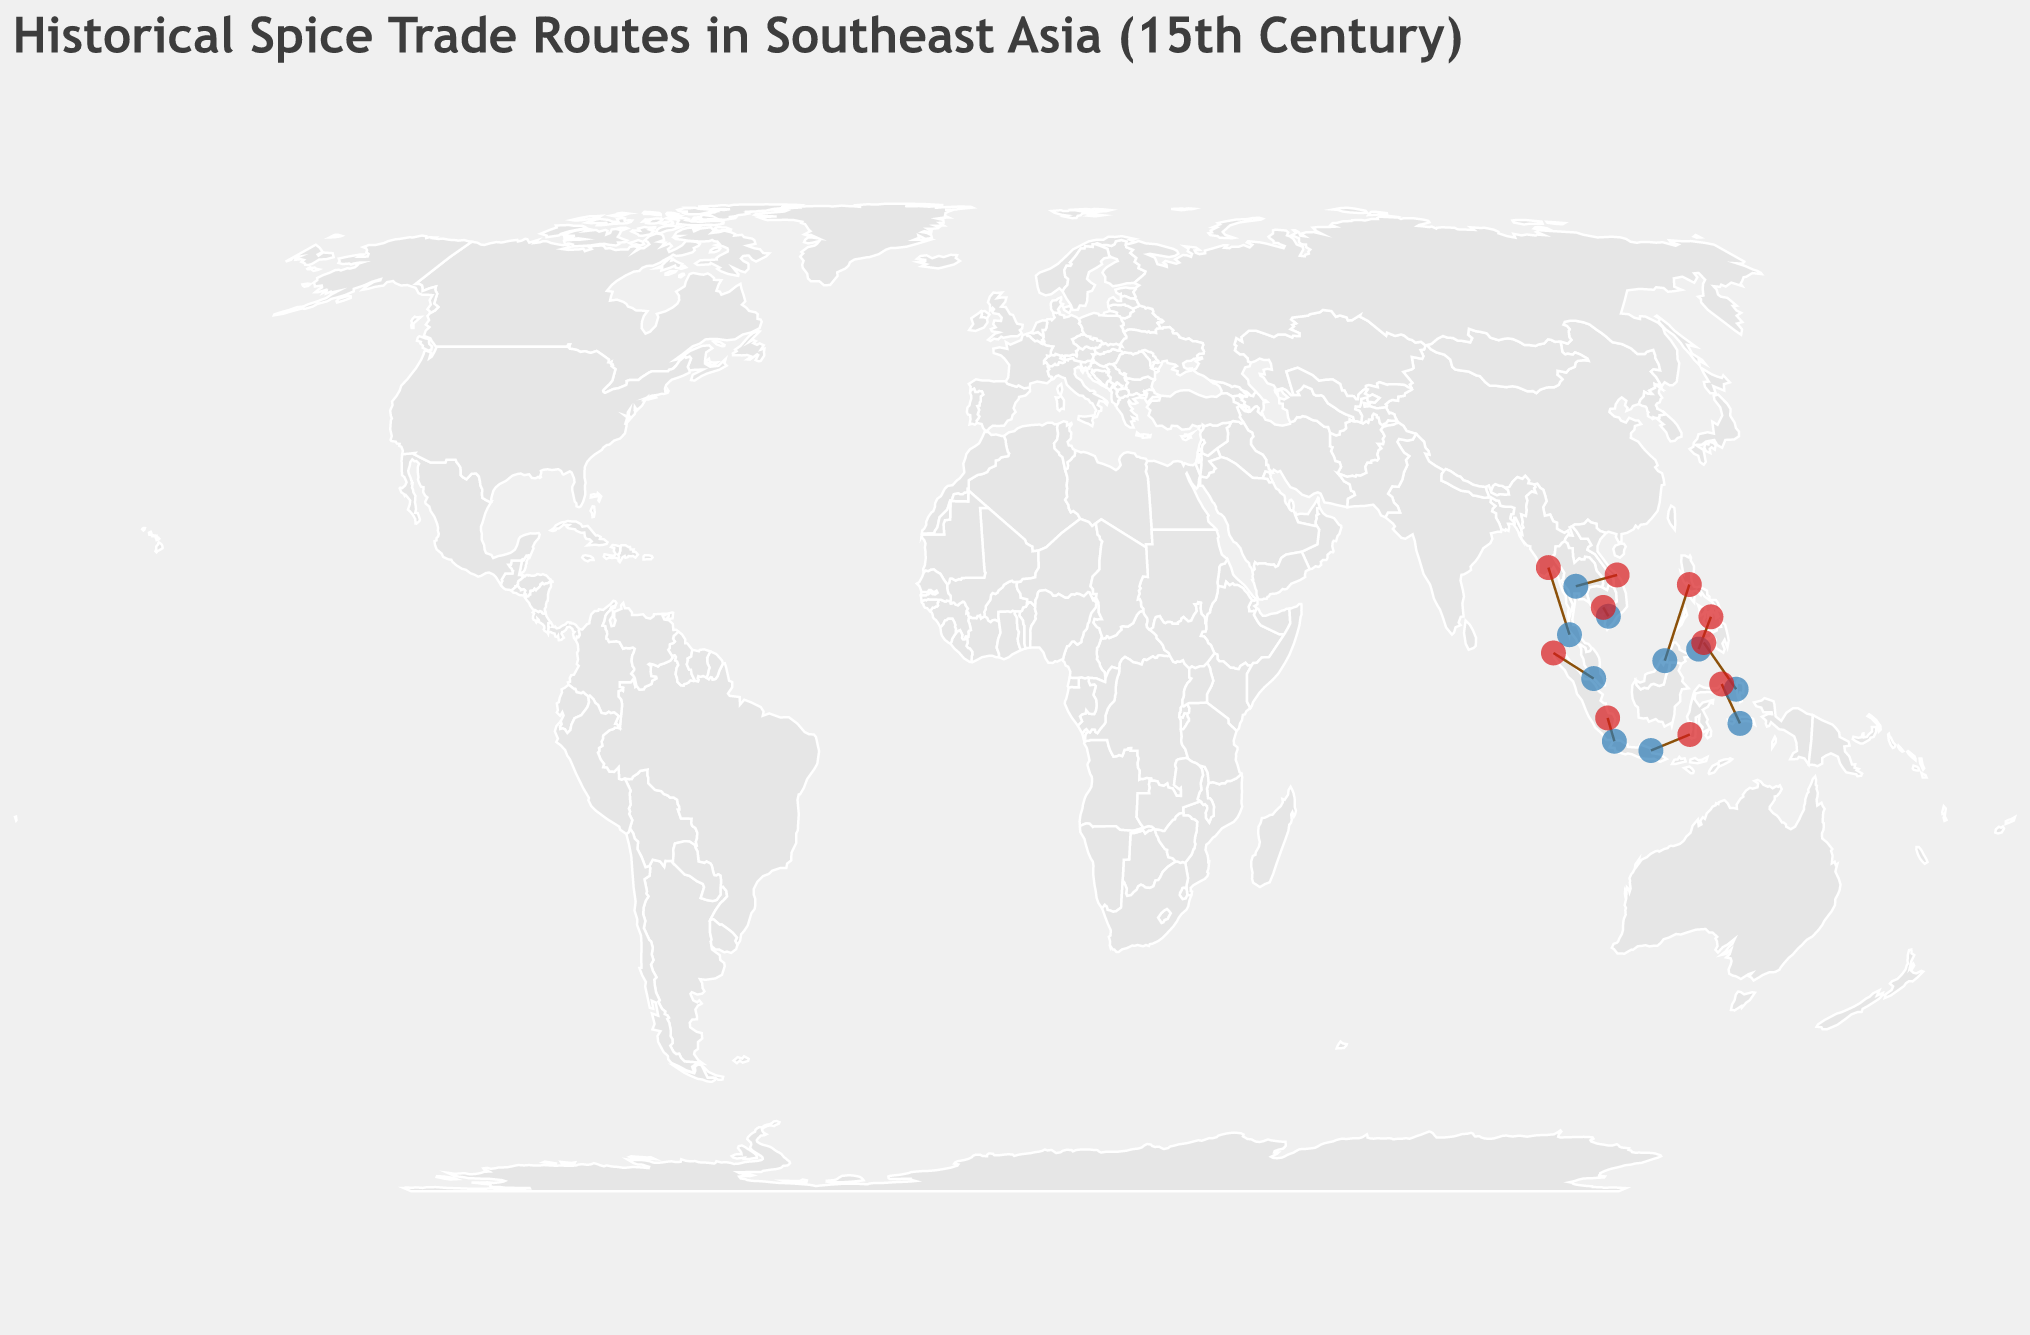What is the title of the figure? The title is prominently displayed at the top of the figure, written in a larger font size. The title reads: "Historical Spice Trade Routes in Southeast Asia (15th Century)."
Answer: Historical Spice Trade Routes in Southeast Asia (15th Century) Which spice had the highest trade volume, and on which route was it traded? By reviewing the tooltips or data points, the highest trade volume is for Black Pepper with a volume of 300 tons/year on the Java Sea Route from Surabaya to Makassar.
Answer: Black Pepper, Java Sea Route What are the start and end points of the Andaman Sea Route? By moving over the trade routes, we can see that the Andaman Sea Route starts in Phuket and ends in Yangon. This is visible in the tooltips attached to the route as well as the circles representing the start and end points.
Answer: Phuket to Yangon Compare the trade volumes of the Sunda Strait Route and the Gulf of Thailand Route. Which one is higher? The volume for each route is shown in the data points. The Sunda Strait Route has a trade volume of 180 tons/year for Cloves, and the Gulf of Thailand Route has 200 tons/year for Ginger. The Gulf of Thailand Route has a higher volume.
Answer: Gulf of Thailand Route What year does the Molucca Sea Route correspond to, and what spice was traded on this route? Hovering over the Molucca Sea Route, we find that it corresponds to the year 1495, and the spice traded on this route was White Pepper.
Answer: 1495, White Pepper What is the total trade volume of all routes combined? To calculate the total trade volume, sum the volumes of each route: 250 (Strait of Malacca) + 180 (Sunda Strait) + 120 (South China Sea) + 300 (Java Sea) + 90 (Celebes Sea) + 150 (Andaman Sea) + 200 (Gulf of Thailand) + 100 (Mekong Delta) + 80 (Sulu Sea) + 220 (Molucca Sea) = 1690 tons/year.
Answer: 1690 tons/year Which route connects Brunei to Manila, and what was the traded spice? By examining the routes, the South China Sea Route connects Brunei to Manila, and the traded spice on this route was Cinnamon.
Answer: South China Sea Route, Cinnamon How did the trade volume of Star Anise on the Sulu Sea Route compare to that of Mace on the Celebes Sea Route? By moving over the trade routes, we find that the Sulu Sea Route had a volume of 80 tons/year for Star Anise, whereas the Celebes Sea Route had 90 tons/year for Mace. Therefore, the volume of Mace is higher by 10 tons/year.
Answer: Mace was higher Are there more trade routes starting from or ending in the Indonesian archipelago (count and list them)? By counting the routes on the map, those starting in Indonesia include the Java Sea Route (Surabaya), Sunda Strait Route (Banten), and Celebes Sea Route (Ternate). Routes ending in Indonesia include Sunda Strait Route (Palembang) and Java Sea Route (Makassar). Thus, there are more routes starting (3) than ending (2) in Indonesia.
Answer: More starting: Starts (Surabaya, Banten, Ternate), Ends (Palembang, Makassar) Which sea had the spice route with the most variety in traded spices? By examining each sea on the map and noting the spices, the Celebes Sea had mace traded, while other seas had only one spice per route. Since the entire plot only shows one route per sea, the comparison is among the individual routes listed. Thus, distinguishing the seas by unique albeit single spices, the Java Sea accounted for Black Pepper but no other route distinction by spice variety visually.
Answer: Each sea had only one spice per route 